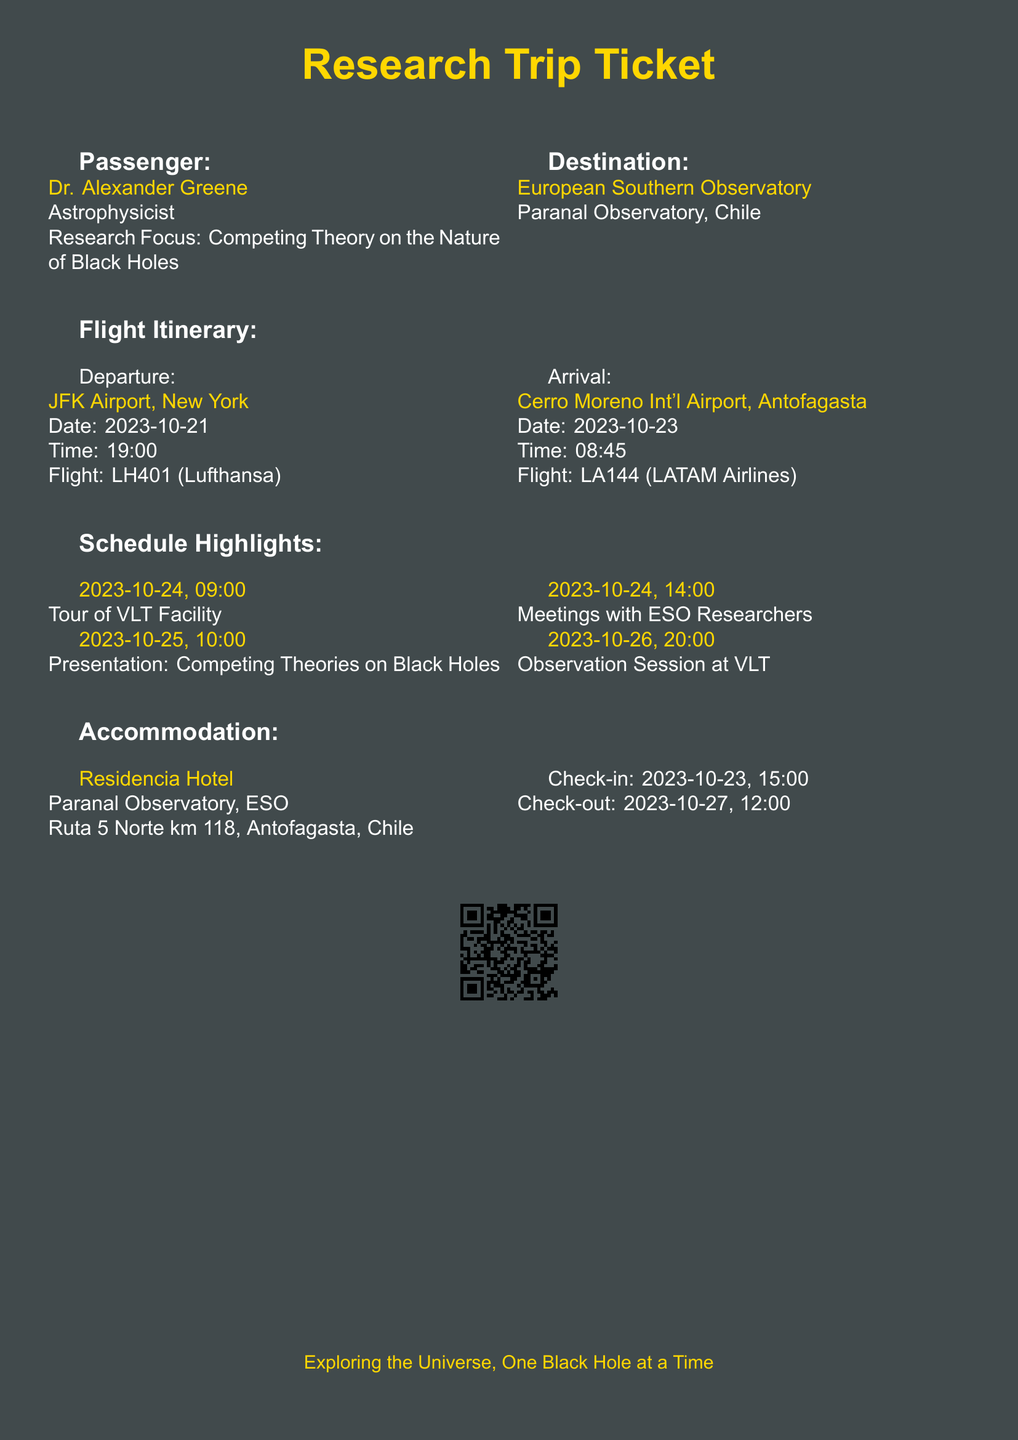What is the passenger's name? The passenger's name is listed at the top of the document as Dr. Alexander Greene.
Answer: Dr. Alexander Greene What is the destination of the flight? The destination is mentioned in the document, specifically stating the European Southern Observatory in Chile.
Answer: European Southern Observatory What is the departure date? The document specifies the departure date for the flight to be on 2023-10-21.
Answer: 2023-10-21 What time does the flight depart? The document indicates the flight departure time as 19:00.
Answer: 19:00 When is the presentation scheduled? The presentation date can be found in the schedule highlights section, specifically listed as 2023-10-25.
Answer: 2023-10-25 Who is the accommodation provider? The document mentions that the accommodation is at the Residencia Hotel.
Answer: Residencia Hotel What is the check-out date for the accommodation? The document states that the check-out date is 2023-10-27.
Answer: 2023-10-27 What event follows the tour of the VLT Facility? In the schedule highlights, the meeting with ESO researchers is outlined as the next event after the tour on 2023-10-24.
Answer: Meetings with ESO Researchers What is the flight number for the departure? The document lists the flight number for the departing flight as LH401.
Answer: LH401 